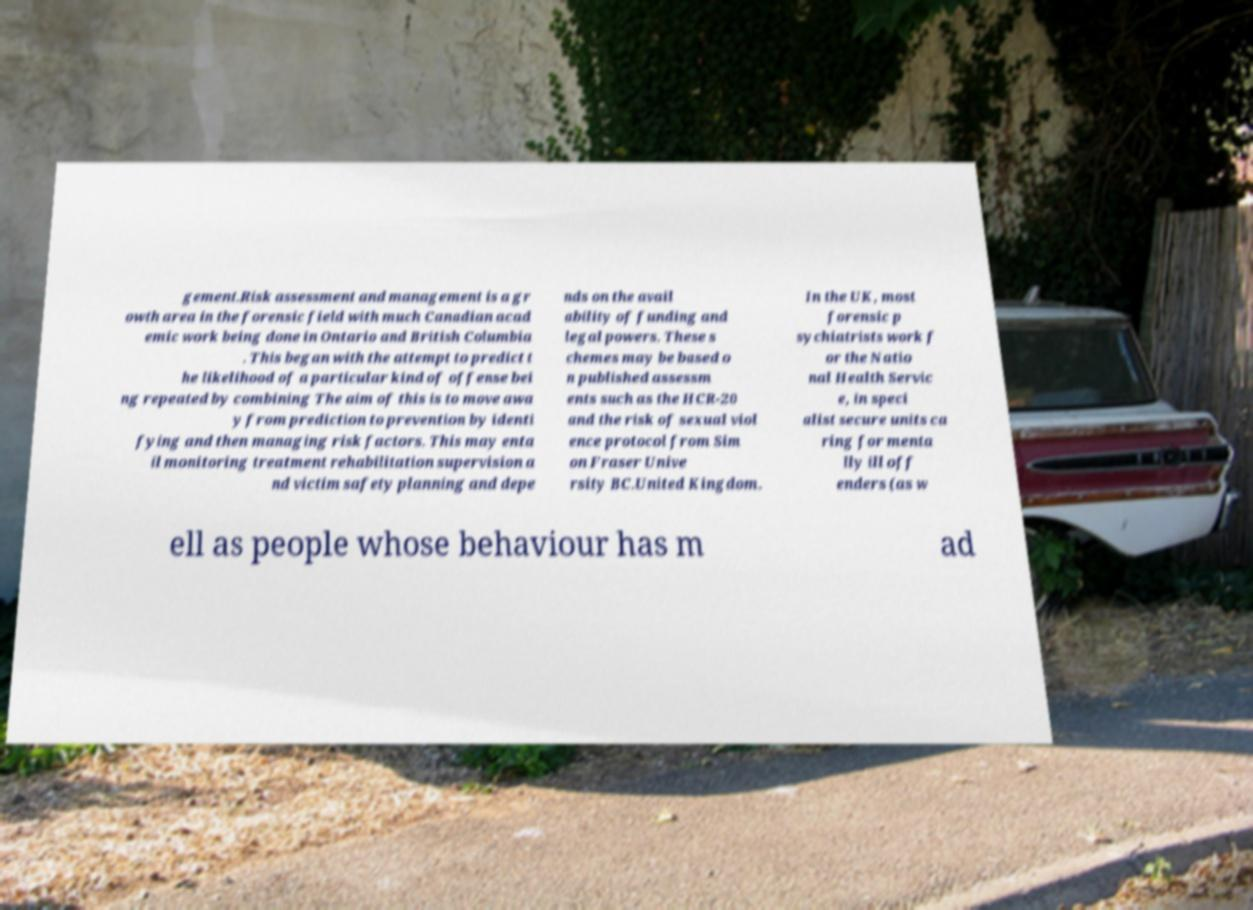Could you assist in decoding the text presented in this image and type it out clearly? gement.Risk assessment and management is a gr owth area in the forensic field with much Canadian acad emic work being done in Ontario and British Columbia . This began with the attempt to predict t he likelihood of a particular kind of offense bei ng repeated by combining The aim of this is to move awa y from prediction to prevention by identi fying and then managing risk factors. This may enta il monitoring treatment rehabilitation supervision a nd victim safety planning and depe nds on the avail ability of funding and legal powers. These s chemes may be based o n published assessm ents such as the HCR-20 and the risk of sexual viol ence protocol from Sim on Fraser Unive rsity BC.United Kingdom. In the UK, most forensic p sychiatrists work f or the Natio nal Health Servic e, in speci alist secure units ca ring for menta lly ill off enders (as w ell as people whose behaviour has m ad 